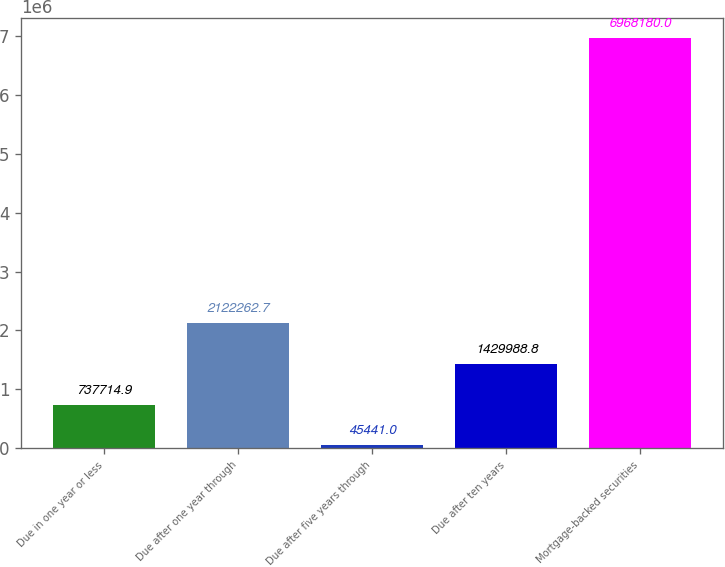<chart> <loc_0><loc_0><loc_500><loc_500><bar_chart><fcel>Due in one year or less<fcel>Due after one year through<fcel>Due after five years through<fcel>Due after ten years<fcel>Mortgage-backed securities<nl><fcel>737715<fcel>2.12226e+06<fcel>45441<fcel>1.42999e+06<fcel>6.96818e+06<nl></chart> 